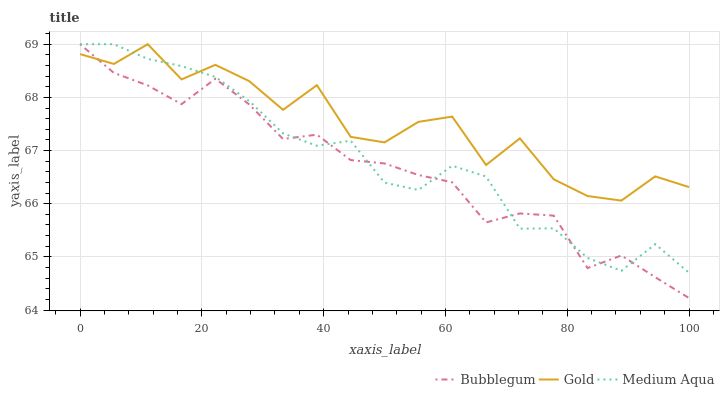Does Bubblegum have the minimum area under the curve?
Answer yes or no. Yes. Does Gold have the maximum area under the curve?
Answer yes or no. Yes. Does Gold have the minimum area under the curve?
Answer yes or no. No. Does Bubblegum have the maximum area under the curve?
Answer yes or no. No. Is Medium Aqua the smoothest?
Answer yes or no. Yes. Is Gold the roughest?
Answer yes or no. Yes. Is Bubblegum the smoothest?
Answer yes or no. No. Is Bubblegum the roughest?
Answer yes or no. No. Does Bubblegum have the lowest value?
Answer yes or no. Yes. Does Gold have the lowest value?
Answer yes or no. No. Does Bubblegum have the highest value?
Answer yes or no. Yes. Does Gold intersect Medium Aqua?
Answer yes or no. Yes. Is Gold less than Medium Aqua?
Answer yes or no. No. Is Gold greater than Medium Aqua?
Answer yes or no. No. 